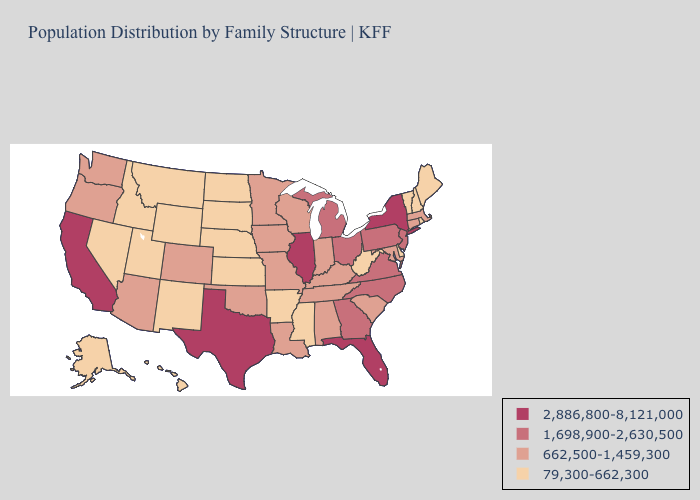Is the legend a continuous bar?
Quick response, please. No. What is the lowest value in states that border Wisconsin?
Give a very brief answer. 662,500-1,459,300. What is the value of Connecticut?
Concise answer only. 662,500-1,459,300. Does Rhode Island have the highest value in the USA?
Concise answer only. No. What is the highest value in the MidWest ?
Quick response, please. 2,886,800-8,121,000. Does the map have missing data?
Answer briefly. No. Among the states that border Florida , does Georgia have the highest value?
Be succinct. Yes. Name the states that have a value in the range 79,300-662,300?
Keep it brief. Alaska, Arkansas, Delaware, Hawaii, Idaho, Kansas, Maine, Mississippi, Montana, Nebraska, Nevada, New Hampshire, New Mexico, North Dakota, Rhode Island, South Dakota, Utah, Vermont, West Virginia, Wyoming. Among the states that border Florida , does Georgia have the highest value?
Answer briefly. Yes. Does Vermont have the highest value in the Northeast?
Answer briefly. No. Name the states that have a value in the range 1,698,900-2,630,500?
Give a very brief answer. Georgia, Michigan, New Jersey, North Carolina, Ohio, Pennsylvania, Virginia. Does Missouri have the highest value in the USA?
Quick response, please. No. Name the states that have a value in the range 79,300-662,300?
Give a very brief answer. Alaska, Arkansas, Delaware, Hawaii, Idaho, Kansas, Maine, Mississippi, Montana, Nebraska, Nevada, New Hampshire, New Mexico, North Dakota, Rhode Island, South Dakota, Utah, Vermont, West Virginia, Wyoming. How many symbols are there in the legend?
Keep it brief. 4. Which states have the highest value in the USA?
Short answer required. California, Florida, Illinois, New York, Texas. 